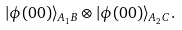<formula> <loc_0><loc_0><loc_500><loc_500>| \phi ( 0 0 ) \rangle _ { A _ { 1 } B } \otimes | \phi ( 0 0 ) \rangle _ { A _ { 2 } C } .</formula> 